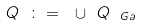<formula> <loc_0><loc_0><loc_500><loc_500>Q \ \colon = \ \cup \ Q _ { \ G a }</formula> 